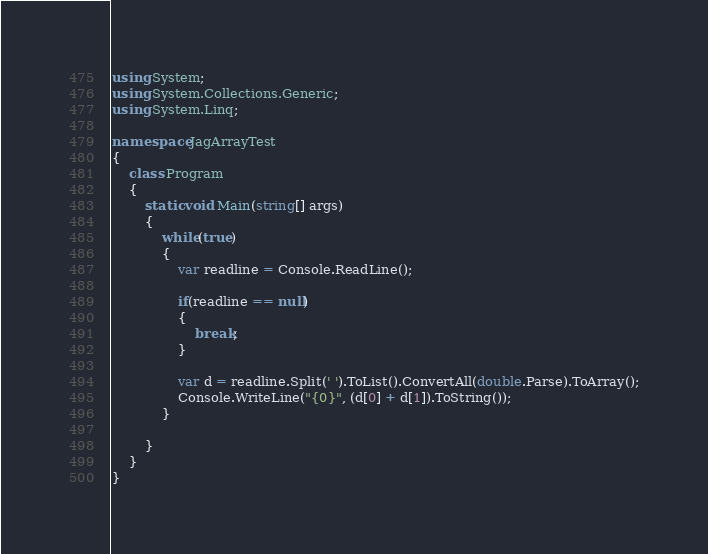<code> <loc_0><loc_0><loc_500><loc_500><_C#_>using System;
using System.Collections.Generic;
using System.Linq;

namespace JagArrayTest
{
    class Program
    {
        static void Main(string[] args)
        {
            while(true)
            {
                var readline = Console.ReadLine();

                if(readline == null)
                {
                    break;
                }

                var d = readline.Split(' ').ToList().ConvertAll(double.Parse).ToArray();
                Console.WriteLine("{0}", (d[0] + d[1]).ToString());
            }

        }
    }
}
</code> 